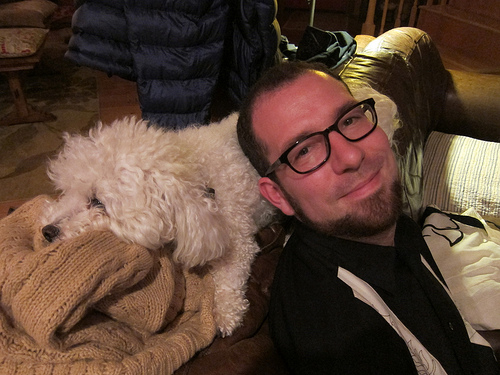<image>
Is the man in the dog? No. The man is not contained within the dog. These objects have a different spatial relationship. 